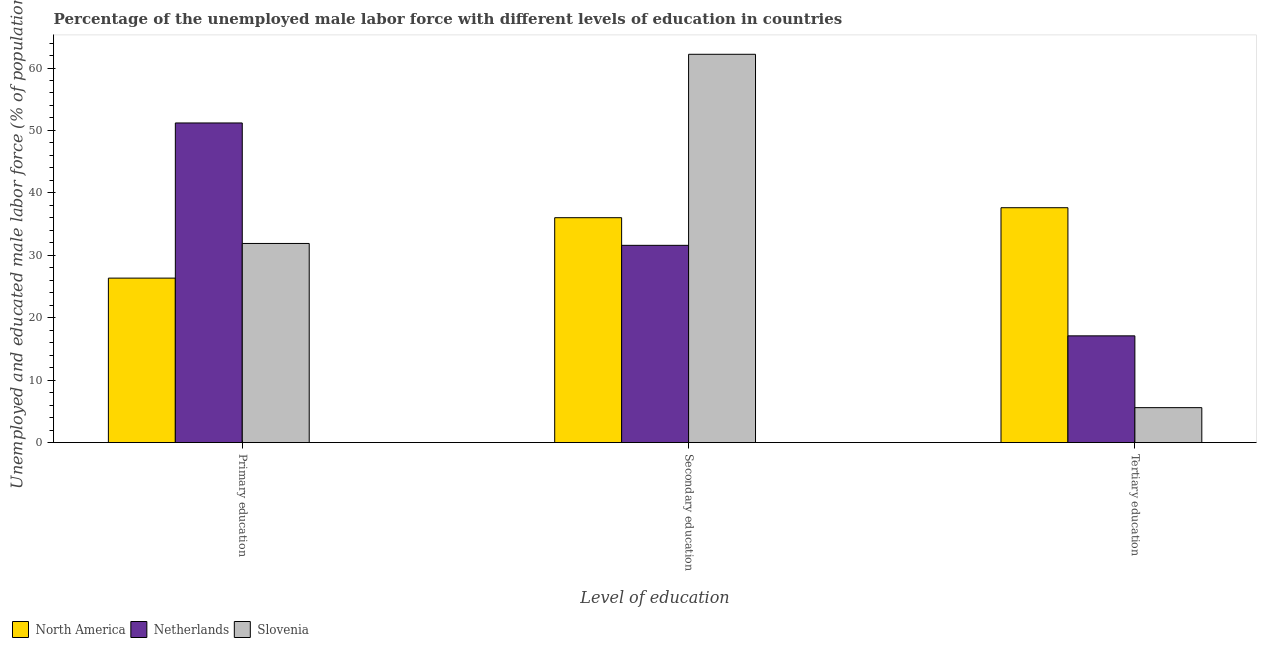Are the number of bars on each tick of the X-axis equal?
Offer a terse response. Yes. What is the label of the 2nd group of bars from the left?
Make the answer very short. Secondary education. What is the percentage of male labor force who received tertiary education in North America?
Ensure brevity in your answer.  37.63. Across all countries, what is the maximum percentage of male labor force who received primary education?
Ensure brevity in your answer.  51.2. Across all countries, what is the minimum percentage of male labor force who received primary education?
Your response must be concise. 26.35. In which country was the percentage of male labor force who received tertiary education maximum?
Provide a short and direct response. North America. What is the total percentage of male labor force who received tertiary education in the graph?
Ensure brevity in your answer.  60.33. What is the difference between the percentage of male labor force who received tertiary education in Slovenia and that in North America?
Ensure brevity in your answer.  -32.03. What is the difference between the percentage of male labor force who received primary education in Netherlands and the percentage of male labor force who received secondary education in North America?
Your answer should be compact. 15.17. What is the average percentage of male labor force who received tertiary education per country?
Offer a very short reply. 20.11. What is the difference between the percentage of male labor force who received tertiary education and percentage of male labor force who received secondary education in North America?
Your answer should be compact. 1.6. What is the ratio of the percentage of male labor force who received tertiary education in Slovenia to that in Netherlands?
Your answer should be compact. 0.33. What is the difference between the highest and the second highest percentage of male labor force who received secondary education?
Ensure brevity in your answer.  26.17. What is the difference between the highest and the lowest percentage of male labor force who received secondary education?
Offer a terse response. 30.6. In how many countries, is the percentage of male labor force who received primary education greater than the average percentage of male labor force who received primary education taken over all countries?
Offer a terse response. 1. Is it the case that in every country, the sum of the percentage of male labor force who received primary education and percentage of male labor force who received secondary education is greater than the percentage of male labor force who received tertiary education?
Ensure brevity in your answer.  Yes. How many bars are there?
Provide a short and direct response. 9. How many countries are there in the graph?
Make the answer very short. 3. Are the values on the major ticks of Y-axis written in scientific E-notation?
Provide a short and direct response. No. Does the graph contain any zero values?
Your answer should be compact. No. Does the graph contain grids?
Offer a very short reply. No. Where does the legend appear in the graph?
Your answer should be very brief. Bottom left. What is the title of the graph?
Ensure brevity in your answer.  Percentage of the unemployed male labor force with different levels of education in countries. What is the label or title of the X-axis?
Ensure brevity in your answer.  Level of education. What is the label or title of the Y-axis?
Your response must be concise. Unemployed and educated male labor force (% of population). What is the Unemployed and educated male labor force (% of population) of North America in Primary education?
Make the answer very short. 26.35. What is the Unemployed and educated male labor force (% of population) in Netherlands in Primary education?
Provide a succinct answer. 51.2. What is the Unemployed and educated male labor force (% of population) in Slovenia in Primary education?
Your answer should be very brief. 31.9. What is the Unemployed and educated male labor force (% of population) of North America in Secondary education?
Give a very brief answer. 36.03. What is the Unemployed and educated male labor force (% of population) in Netherlands in Secondary education?
Keep it short and to the point. 31.6. What is the Unemployed and educated male labor force (% of population) in Slovenia in Secondary education?
Offer a terse response. 62.2. What is the Unemployed and educated male labor force (% of population) of North America in Tertiary education?
Give a very brief answer. 37.63. What is the Unemployed and educated male labor force (% of population) of Netherlands in Tertiary education?
Provide a succinct answer. 17.1. What is the Unemployed and educated male labor force (% of population) of Slovenia in Tertiary education?
Keep it short and to the point. 5.6. Across all Level of education, what is the maximum Unemployed and educated male labor force (% of population) in North America?
Offer a terse response. 37.63. Across all Level of education, what is the maximum Unemployed and educated male labor force (% of population) of Netherlands?
Provide a succinct answer. 51.2. Across all Level of education, what is the maximum Unemployed and educated male labor force (% of population) in Slovenia?
Provide a short and direct response. 62.2. Across all Level of education, what is the minimum Unemployed and educated male labor force (% of population) in North America?
Offer a very short reply. 26.35. Across all Level of education, what is the minimum Unemployed and educated male labor force (% of population) in Netherlands?
Provide a succinct answer. 17.1. Across all Level of education, what is the minimum Unemployed and educated male labor force (% of population) in Slovenia?
Give a very brief answer. 5.6. What is the total Unemployed and educated male labor force (% of population) in Netherlands in the graph?
Provide a succinct answer. 99.9. What is the total Unemployed and educated male labor force (% of population) of Slovenia in the graph?
Offer a very short reply. 99.7. What is the difference between the Unemployed and educated male labor force (% of population) in North America in Primary education and that in Secondary education?
Offer a very short reply. -9.68. What is the difference between the Unemployed and educated male labor force (% of population) of Netherlands in Primary education and that in Secondary education?
Your answer should be very brief. 19.6. What is the difference between the Unemployed and educated male labor force (% of population) in Slovenia in Primary education and that in Secondary education?
Give a very brief answer. -30.3. What is the difference between the Unemployed and educated male labor force (% of population) in North America in Primary education and that in Tertiary education?
Keep it short and to the point. -11.28. What is the difference between the Unemployed and educated male labor force (% of population) in Netherlands in Primary education and that in Tertiary education?
Your response must be concise. 34.1. What is the difference between the Unemployed and educated male labor force (% of population) of Slovenia in Primary education and that in Tertiary education?
Your answer should be very brief. 26.3. What is the difference between the Unemployed and educated male labor force (% of population) in North America in Secondary education and that in Tertiary education?
Give a very brief answer. -1.6. What is the difference between the Unemployed and educated male labor force (% of population) of Slovenia in Secondary education and that in Tertiary education?
Offer a terse response. 56.6. What is the difference between the Unemployed and educated male labor force (% of population) of North America in Primary education and the Unemployed and educated male labor force (% of population) of Netherlands in Secondary education?
Your answer should be compact. -5.25. What is the difference between the Unemployed and educated male labor force (% of population) in North America in Primary education and the Unemployed and educated male labor force (% of population) in Slovenia in Secondary education?
Ensure brevity in your answer.  -35.85. What is the difference between the Unemployed and educated male labor force (% of population) in Netherlands in Primary education and the Unemployed and educated male labor force (% of population) in Slovenia in Secondary education?
Offer a very short reply. -11. What is the difference between the Unemployed and educated male labor force (% of population) in North America in Primary education and the Unemployed and educated male labor force (% of population) in Netherlands in Tertiary education?
Your answer should be very brief. 9.25. What is the difference between the Unemployed and educated male labor force (% of population) of North America in Primary education and the Unemployed and educated male labor force (% of population) of Slovenia in Tertiary education?
Make the answer very short. 20.75. What is the difference between the Unemployed and educated male labor force (% of population) of Netherlands in Primary education and the Unemployed and educated male labor force (% of population) of Slovenia in Tertiary education?
Keep it short and to the point. 45.6. What is the difference between the Unemployed and educated male labor force (% of population) of North America in Secondary education and the Unemployed and educated male labor force (% of population) of Netherlands in Tertiary education?
Offer a terse response. 18.93. What is the difference between the Unemployed and educated male labor force (% of population) of North America in Secondary education and the Unemployed and educated male labor force (% of population) of Slovenia in Tertiary education?
Offer a terse response. 30.43. What is the difference between the Unemployed and educated male labor force (% of population) in Netherlands in Secondary education and the Unemployed and educated male labor force (% of population) in Slovenia in Tertiary education?
Your answer should be very brief. 26. What is the average Unemployed and educated male labor force (% of population) in North America per Level of education?
Offer a very short reply. 33.33. What is the average Unemployed and educated male labor force (% of population) in Netherlands per Level of education?
Ensure brevity in your answer.  33.3. What is the average Unemployed and educated male labor force (% of population) in Slovenia per Level of education?
Provide a short and direct response. 33.23. What is the difference between the Unemployed and educated male labor force (% of population) in North America and Unemployed and educated male labor force (% of population) in Netherlands in Primary education?
Make the answer very short. -24.85. What is the difference between the Unemployed and educated male labor force (% of population) in North America and Unemployed and educated male labor force (% of population) in Slovenia in Primary education?
Provide a succinct answer. -5.55. What is the difference between the Unemployed and educated male labor force (% of population) of Netherlands and Unemployed and educated male labor force (% of population) of Slovenia in Primary education?
Your response must be concise. 19.3. What is the difference between the Unemployed and educated male labor force (% of population) of North America and Unemployed and educated male labor force (% of population) of Netherlands in Secondary education?
Provide a succinct answer. 4.43. What is the difference between the Unemployed and educated male labor force (% of population) of North America and Unemployed and educated male labor force (% of population) of Slovenia in Secondary education?
Make the answer very short. -26.17. What is the difference between the Unemployed and educated male labor force (% of population) in Netherlands and Unemployed and educated male labor force (% of population) in Slovenia in Secondary education?
Your answer should be compact. -30.6. What is the difference between the Unemployed and educated male labor force (% of population) in North America and Unemployed and educated male labor force (% of population) in Netherlands in Tertiary education?
Your answer should be very brief. 20.53. What is the difference between the Unemployed and educated male labor force (% of population) of North America and Unemployed and educated male labor force (% of population) of Slovenia in Tertiary education?
Make the answer very short. 32.03. What is the ratio of the Unemployed and educated male labor force (% of population) in North America in Primary education to that in Secondary education?
Your answer should be very brief. 0.73. What is the ratio of the Unemployed and educated male labor force (% of population) of Netherlands in Primary education to that in Secondary education?
Offer a very short reply. 1.62. What is the ratio of the Unemployed and educated male labor force (% of population) in Slovenia in Primary education to that in Secondary education?
Your response must be concise. 0.51. What is the ratio of the Unemployed and educated male labor force (% of population) in North America in Primary education to that in Tertiary education?
Keep it short and to the point. 0.7. What is the ratio of the Unemployed and educated male labor force (% of population) in Netherlands in Primary education to that in Tertiary education?
Provide a succinct answer. 2.99. What is the ratio of the Unemployed and educated male labor force (% of population) in Slovenia in Primary education to that in Tertiary education?
Offer a very short reply. 5.7. What is the ratio of the Unemployed and educated male labor force (% of population) of North America in Secondary education to that in Tertiary education?
Offer a terse response. 0.96. What is the ratio of the Unemployed and educated male labor force (% of population) in Netherlands in Secondary education to that in Tertiary education?
Offer a terse response. 1.85. What is the ratio of the Unemployed and educated male labor force (% of population) of Slovenia in Secondary education to that in Tertiary education?
Your response must be concise. 11.11. What is the difference between the highest and the second highest Unemployed and educated male labor force (% of population) in North America?
Your answer should be very brief. 1.6. What is the difference between the highest and the second highest Unemployed and educated male labor force (% of population) in Netherlands?
Give a very brief answer. 19.6. What is the difference between the highest and the second highest Unemployed and educated male labor force (% of population) of Slovenia?
Make the answer very short. 30.3. What is the difference between the highest and the lowest Unemployed and educated male labor force (% of population) in North America?
Keep it short and to the point. 11.28. What is the difference between the highest and the lowest Unemployed and educated male labor force (% of population) of Netherlands?
Offer a very short reply. 34.1. What is the difference between the highest and the lowest Unemployed and educated male labor force (% of population) of Slovenia?
Your answer should be compact. 56.6. 